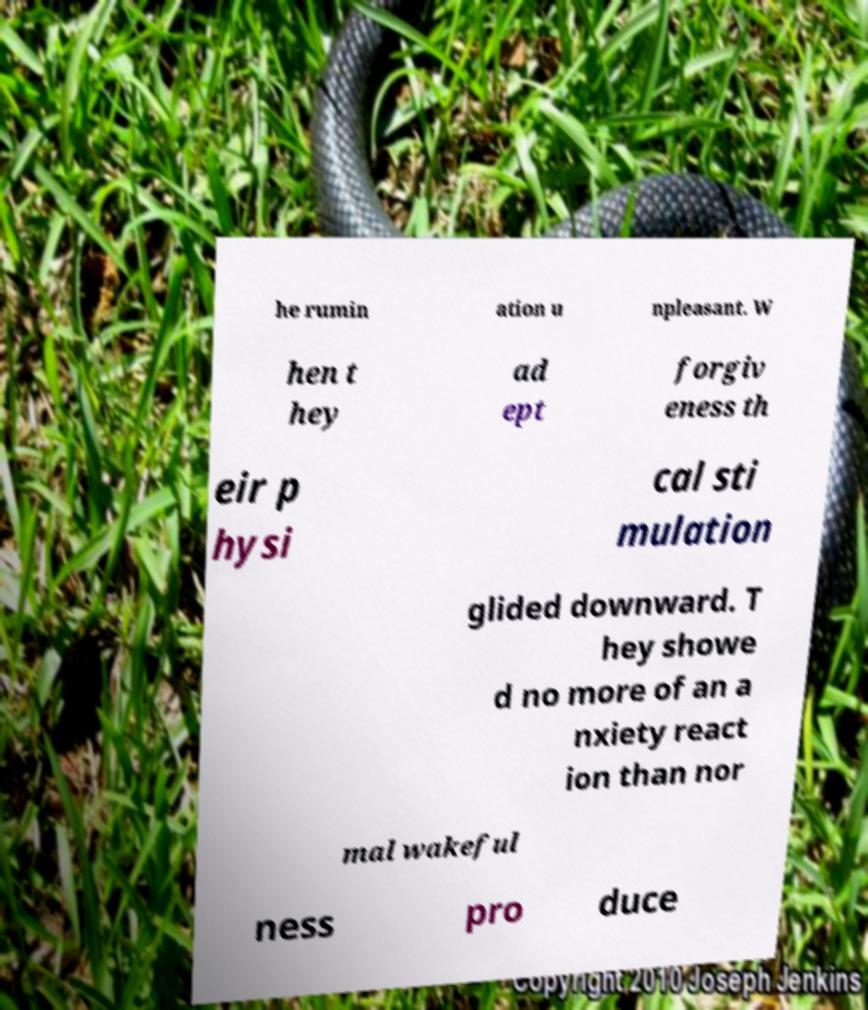Can you read and provide the text displayed in the image?This photo seems to have some interesting text. Can you extract and type it out for me? he rumin ation u npleasant. W hen t hey ad ept forgiv eness th eir p hysi cal sti mulation glided downward. T hey showe d no more of an a nxiety react ion than nor mal wakeful ness pro duce 